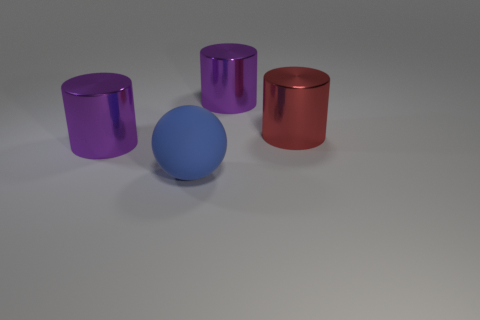Subtract all big red cylinders. How many cylinders are left? 2 Subtract all red spheres. How many purple cylinders are left? 2 Add 2 red metallic cylinders. How many objects exist? 6 Subtract 1 cylinders. How many cylinders are left? 2 Subtract all cylinders. How many objects are left? 1 Add 1 large purple shiny things. How many large purple shiny things are left? 3 Add 2 large shiny cylinders. How many large shiny cylinders exist? 5 Subtract 0 red balls. How many objects are left? 4 Subtract all green cylinders. Subtract all brown spheres. How many cylinders are left? 3 Subtract all large green rubber things. Subtract all purple shiny cylinders. How many objects are left? 2 